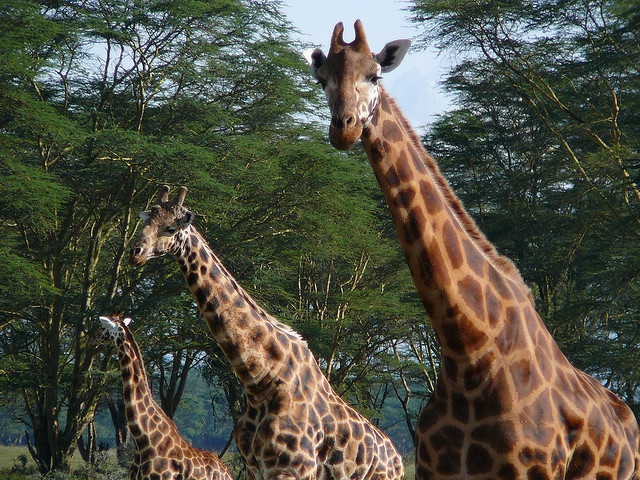Describe the objects in this image and their specific colors. I can see giraffe in black, gray, maroon, and tan tones, giraffe in black, gray, and tan tones, and giraffe in black, gray, and maroon tones in this image. 